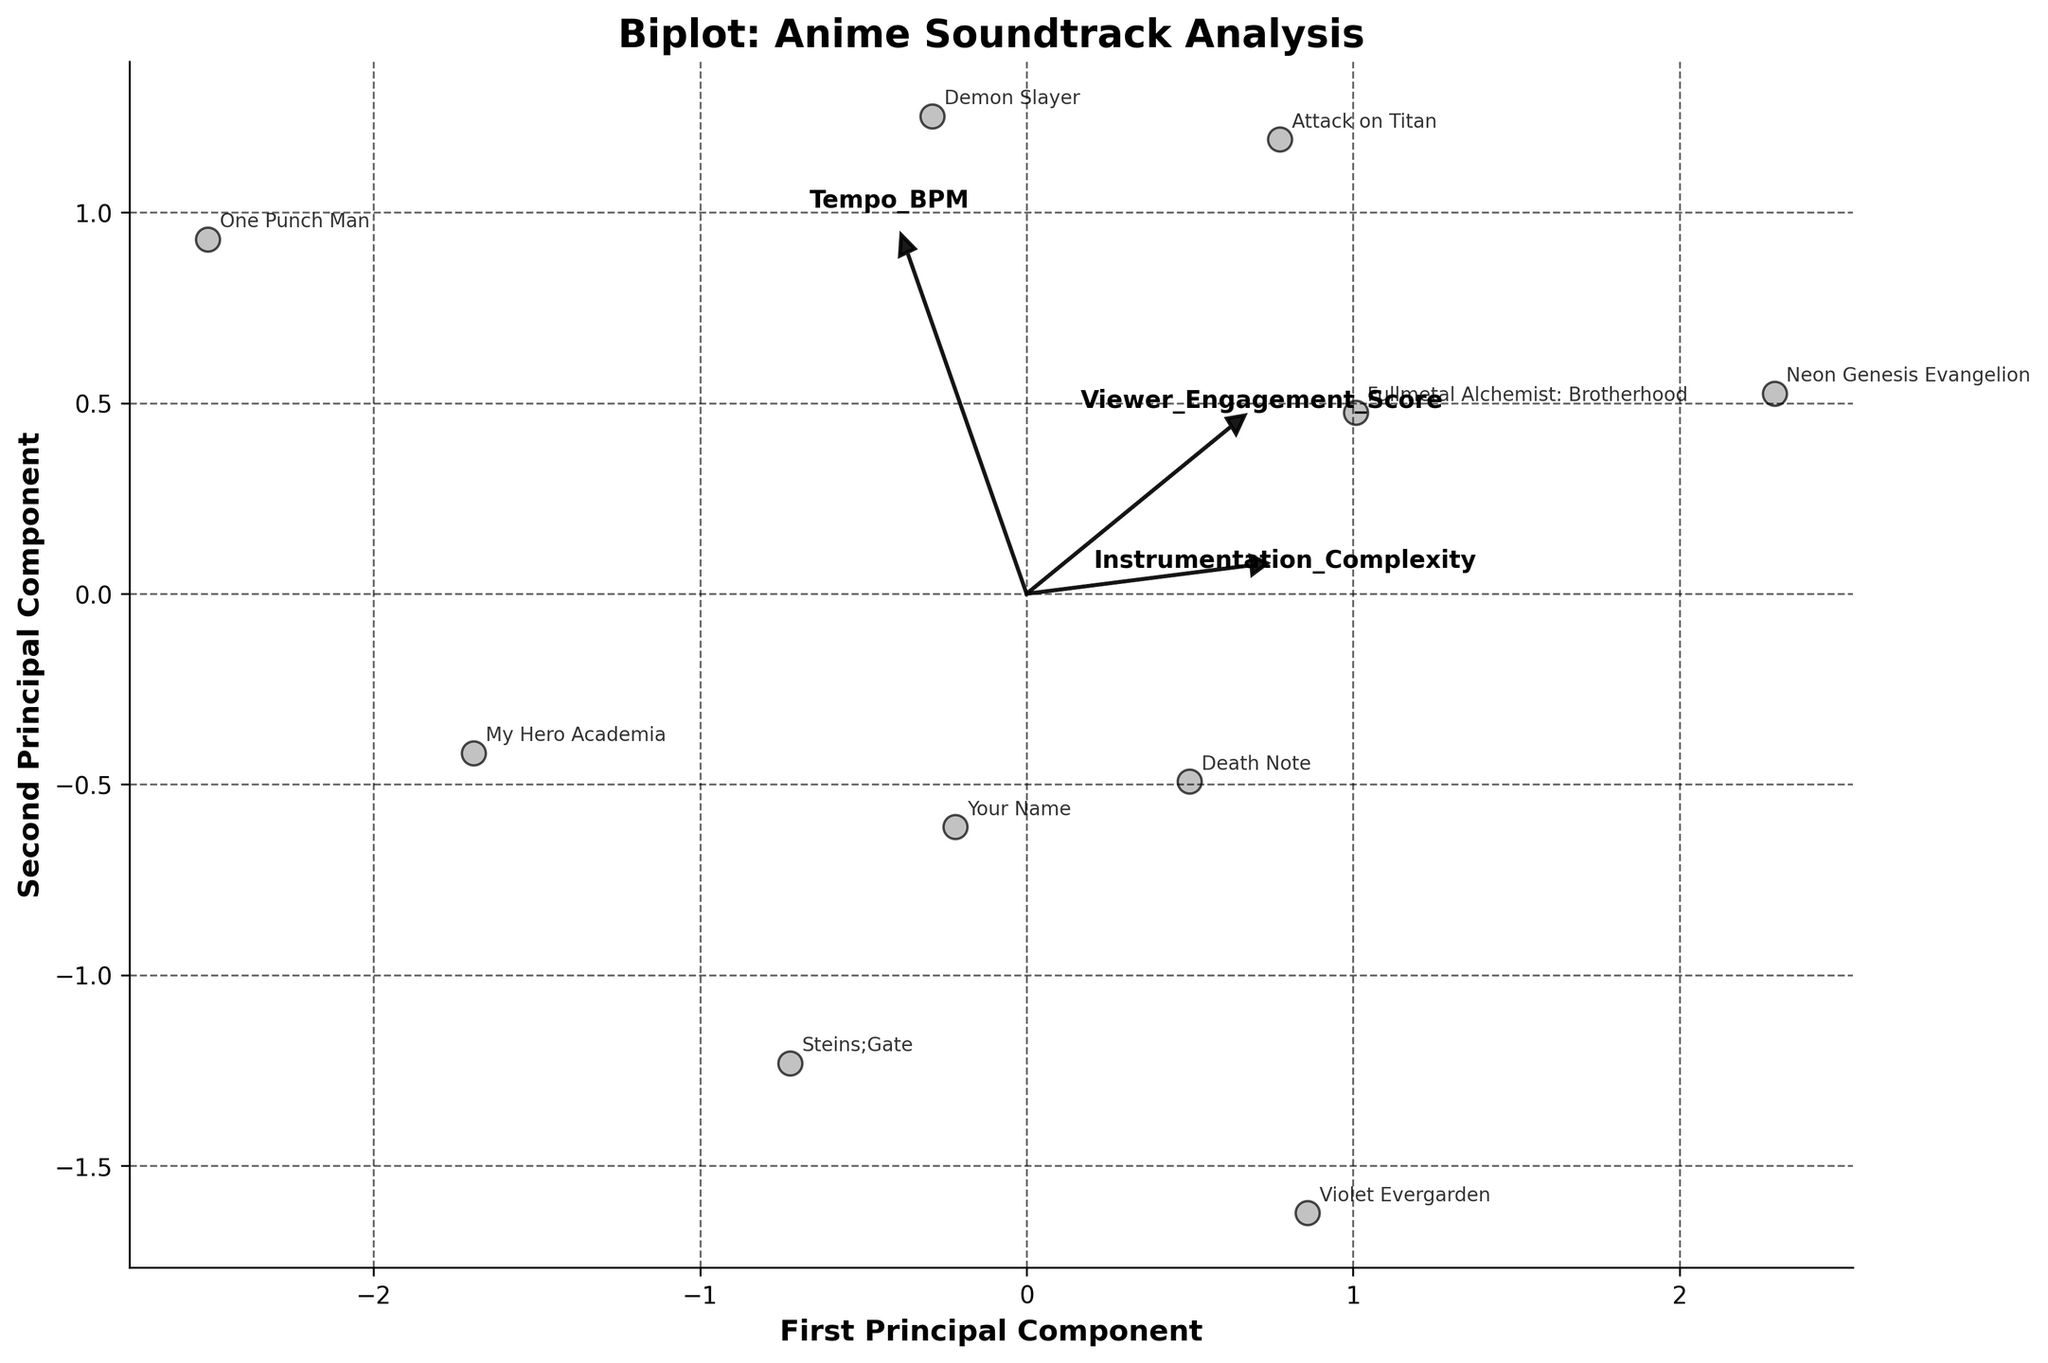How many principal components are being displayed in the plot? The plot has two axes labeled "First Principal Component" and "Second Principal Component," indicating the number of principal components shown.
Answer: 2 Which anime has the highest Value for the second principal component? Looking at the position of the points along the second axis (Second Principal Component), “Neon Genesis Evangelion” appears to be the highest.
Answer: Neon Genesis Evangelion Which features are represented by the arrows in the biplot? The arrows have labels that indicate the features they represent. The three labels are "Instrumentation_Complexity," "Tempo_BPM," and "Viewer_Engagement_Score."
Answer: Instrumentation_Complexity, Tempo_BPM, Viewer_Engagement_Score How does the tempo BPM arrow correlate with the first principal component? The Tempo_BPM arrow points mostly in the horizontal direction, indicating a high positive correlation with the first principal component.
Answer: High positive correlation Which anime has the lowest value for the first principal component, and what might that indicate about its soundtrack complexity and tempo? "One Punch Man” is positioned farthest to the left along the first principal component, suggesting lower instrumentation complexity and/or tempo BPM compared to others.
Answer: One Punch Man Are the anime titles from the "Action" genre closer together or spread apart in the biplot? Observing the positions of titles like "Attack on Titan" within the biplot, they appear to be relatively spread apart rather than clustered close together.
Answer: Spread apart Which feature contributes most significantly to the second principal component based on the arrow direction and length? The length and direction of the arrows in the biplot suggest that "Viewer_Engagement_Score" has the highest contribution to the second principal component.
Answer: Viewer_Engagement_Score Is there a visible trend between "Instrumentation_Complexity" and "Viewer_Engagement_Score" in the biplot? Judging by the direction of the arrows, both "Instrumentation_Complexity" and "Viewer_Engagement_Score" point in similar directions, suggesting a positive correlation.
Answer: Positive correlation Which anime has high instrumentation complexity and high viewer engagement according to the first and second principal components? "Neon Genesis Evangelion" and "Attack on Titan" have points that align well with both the first and second principal components, suggesting high values in instrumentation complexity and viewer engagement.
Answer: Neon Genesis Evangelion, Attack on Titan 